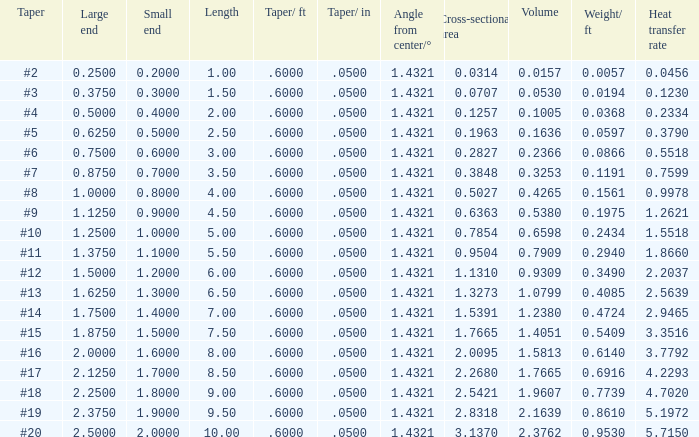Which Taper/ft that has a Large end smaller than 0.5, and a Taper of #2? 0.6. 